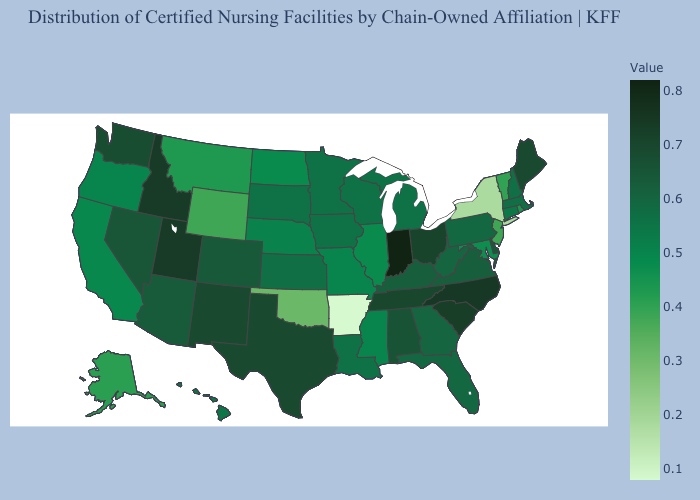Among the states that border New Jersey , which have the highest value?
Keep it brief. Delaware. Does Delaware have the lowest value in the South?
Be succinct. No. Is the legend a continuous bar?
Write a very short answer. Yes. Among the states that border Maryland , does West Virginia have the lowest value?
Short answer required. No. Does Connecticut have a higher value than Alabama?
Be succinct. No. Does Indiana have the highest value in the USA?
Write a very short answer. Yes. Does the map have missing data?
Write a very short answer. No. Does Arkansas have the lowest value in the USA?
Give a very brief answer. Yes. Does Indiana have a lower value than Oklahoma?
Concise answer only. No. 